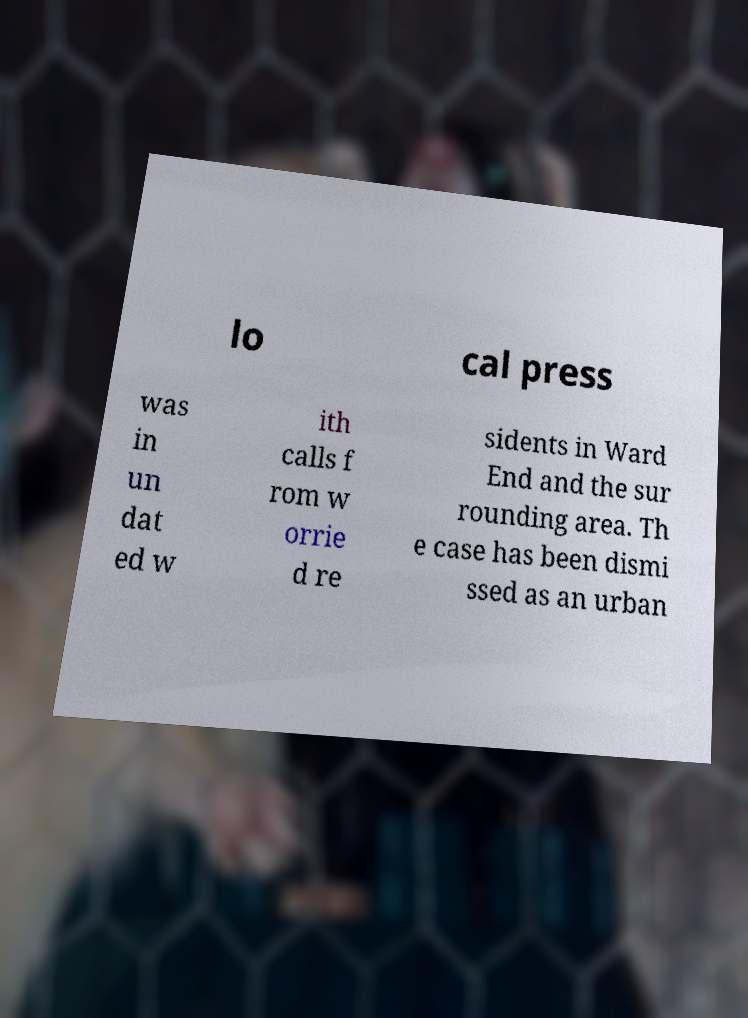What messages or text are displayed in this image? I need them in a readable, typed format. lo cal press was in un dat ed w ith calls f rom w orrie d re sidents in Ward End and the sur rounding area. Th e case has been dismi ssed as an urban 